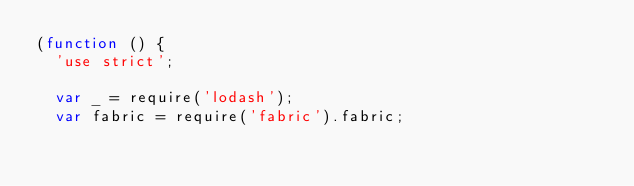<code> <loc_0><loc_0><loc_500><loc_500><_JavaScript_>(function () {
  'use strict';

  var _ = require('lodash');
  var fabric = require('fabric').fabric;
</code> 